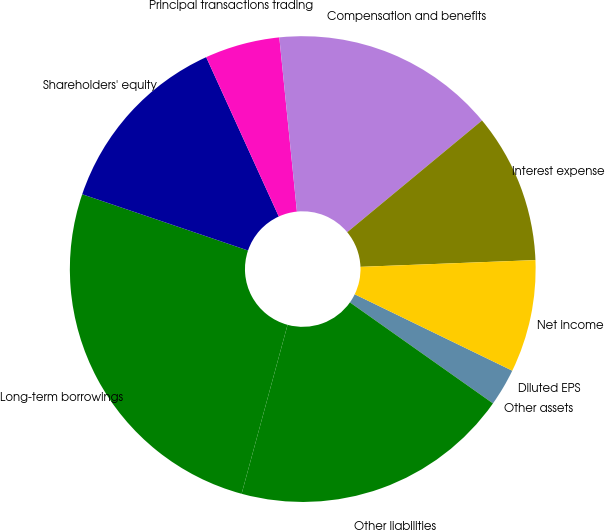<chart> <loc_0><loc_0><loc_500><loc_500><pie_chart><fcel>Other assets<fcel>Other liabilities<fcel>Long-term borrowings<fcel>Shareholders' equity<fcel>Principal transactions trading<fcel>Compensation and benefits<fcel>Interest expense<fcel>Net income<fcel>Diluted EPS<nl><fcel>2.6%<fcel>19.44%<fcel>25.98%<fcel>12.99%<fcel>5.2%<fcel>15.59%<fcel>10.4%<fcel>7.8%<fcel>0.0%<nl></chart> 